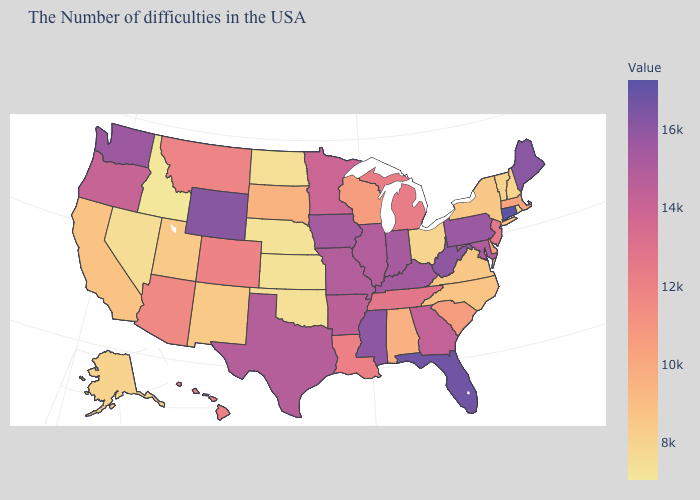Which states have the highest value in the USA?
Short answer required. Connecticut. Which states have the lowest value in the USA?
Be succinct. Idaho. Among the states that border Iowa , which have the highest value?
Short answer required. Missouri. 